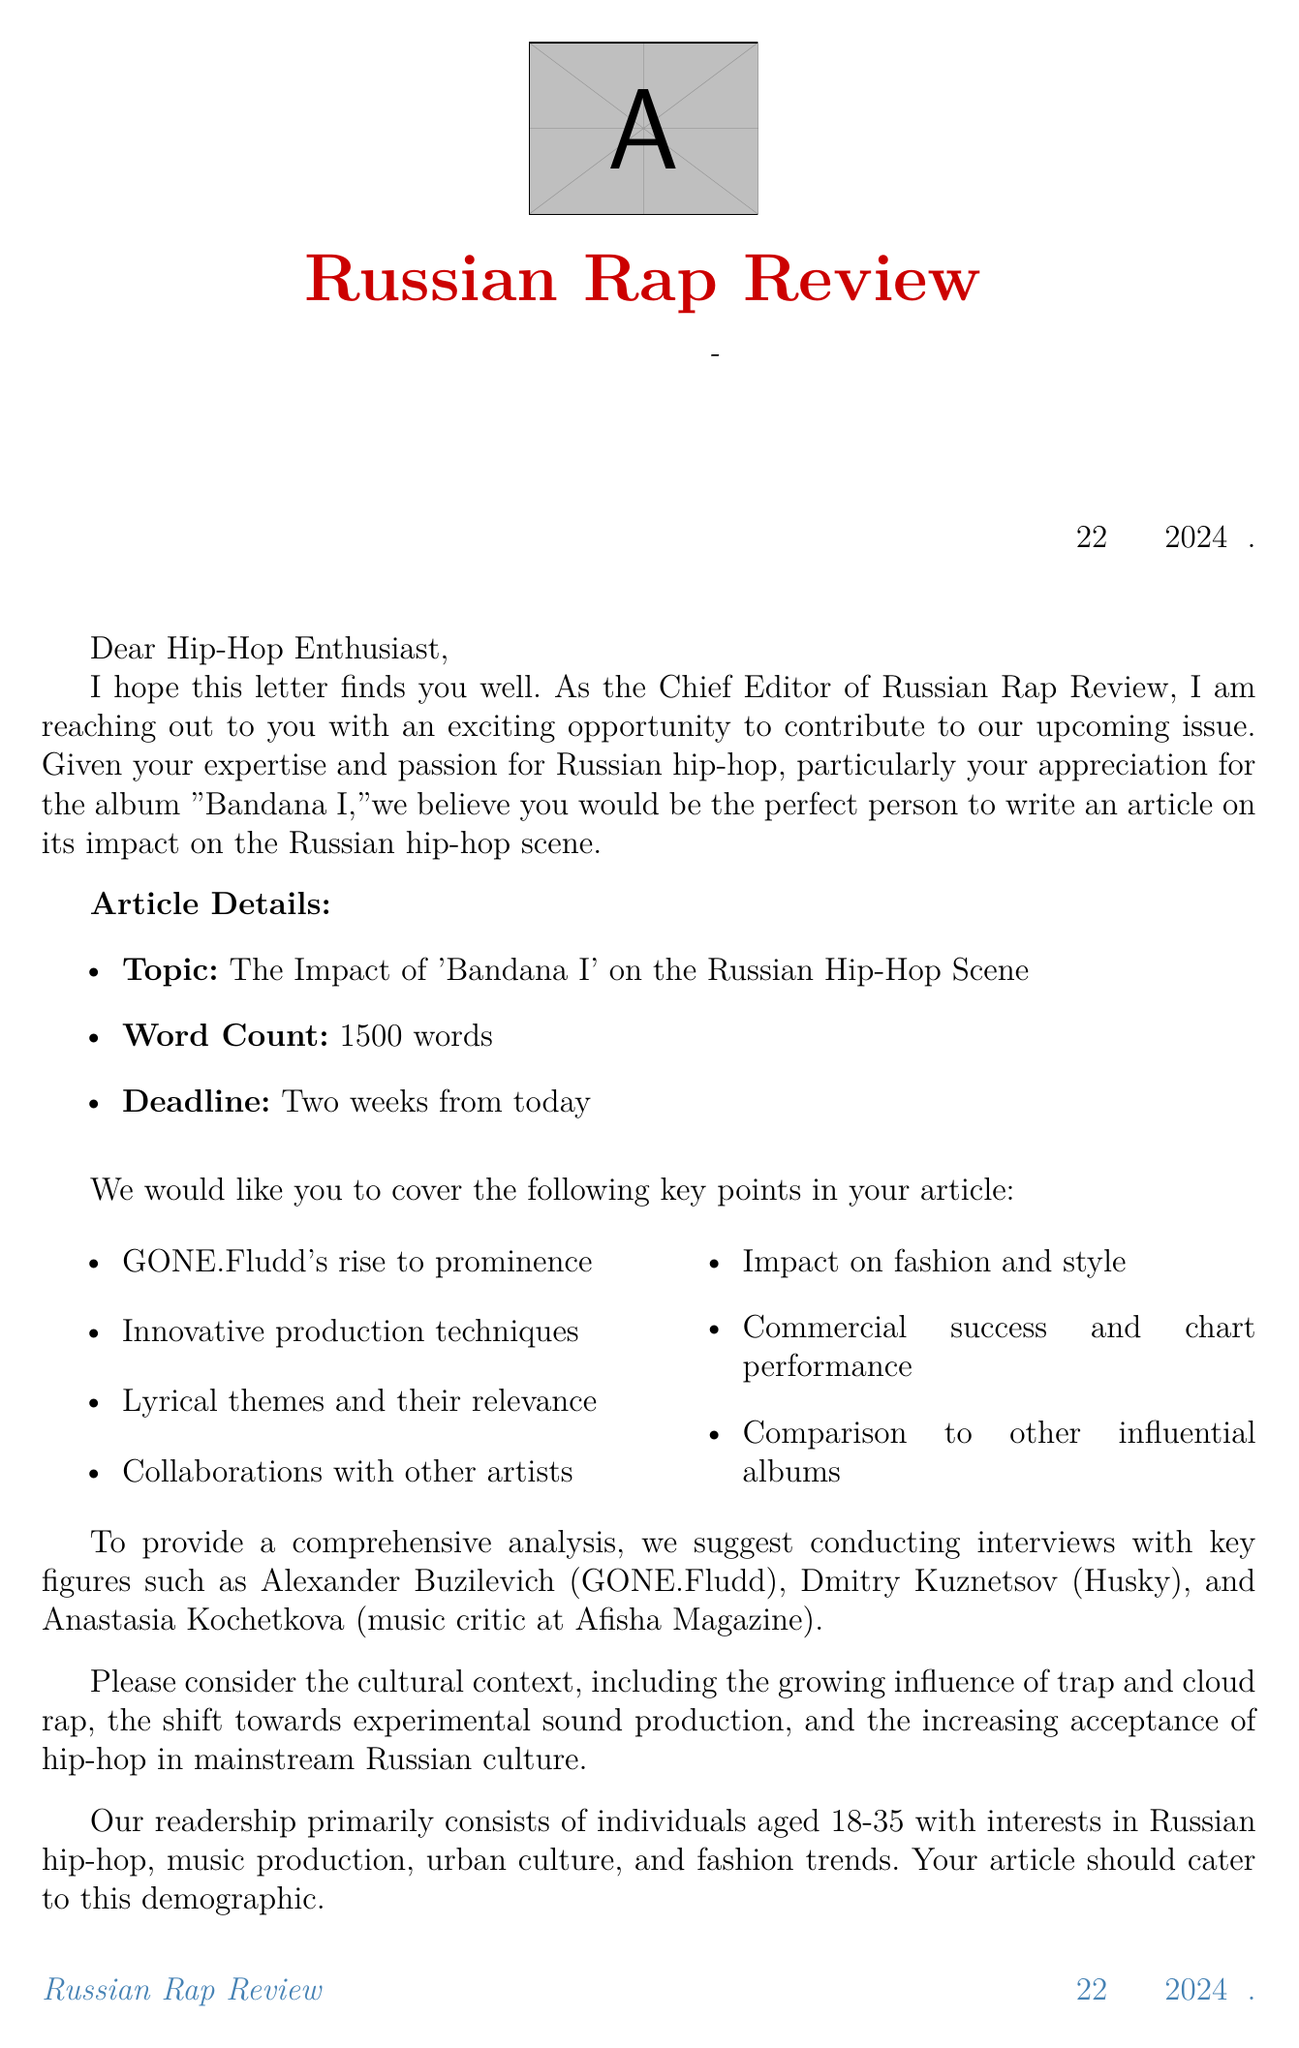What is the name of the magazine? The magazine mentioned in the document is called "Russian Rap Review."
Answer: Russian Rap Review Who is the Chief Editor? The letter states that the Chief Editor is Alexey Volkov.
Answer: Alexey Volkov What is the article's word count requirement? The document requests that the article be 1500 words long.
Answer: 1500 words What is the release date of "Bandana I"? The album "Bandana I" was released on November 1, 2019.
Answer: November 1, 2019 Which artist created "Bandana I"? "Bandana I" was created by the artist GONE.Fludd.
Answer: GONE.Fludd What is one of the key points to cover in the article? One of the key points mentioned is GONE.Fludd's rise to prominence.
Answer: GONE.Fludd's rise to prominence Who is suggested to be interviewed for the article? One suggested interviewee is Alexander Buzilevich, also known as GONE.Fludd.
Answer: Alexander Buzilevich What is the primary age range of the readership? The readership primarily consists of individuals aged 18-35.
Answer: 18-35 What genre of music is mentioned as having a growing influence in Russian hip-hop? The document refers to the growing influence of trap and cloud rap.
Answer: trap and cloud rap 